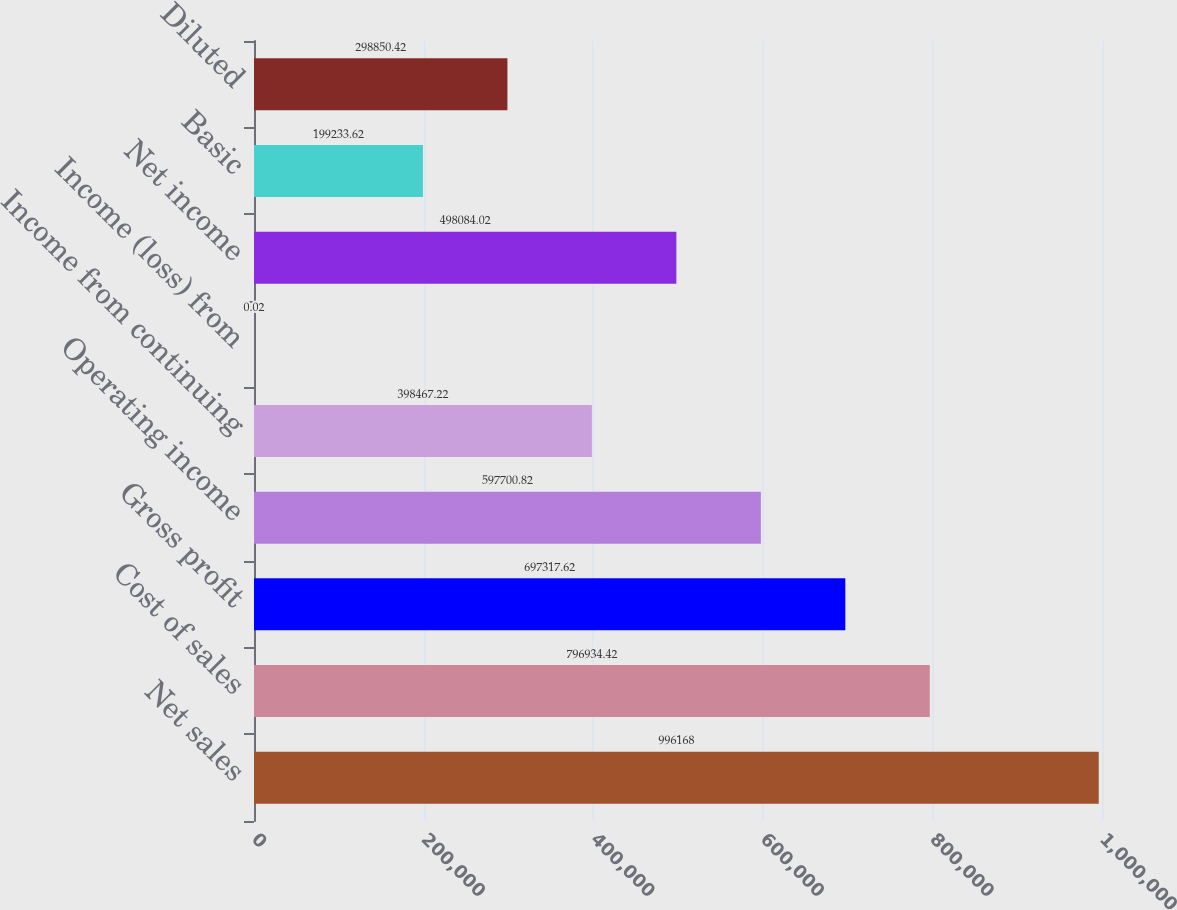Convert chart to OTSL. <chart><loc_0><loc_0><loc_500><loc_500><bar_chart><fcel>Net sales<fcel>Cost of sales<fcel>Gross profit<fcel>Operating income<fcel>Income from continuing<fcel>Income (loss) from<fcel>Net income<fcel>Basic<fcel>Diluted<nl><fcel>996168<fcel>796934<fcel>697318<fcel>597701<fcel>398467<fcel>0.02<fcel>498084<fcel>199234<fcel>298850<nl></chart> 